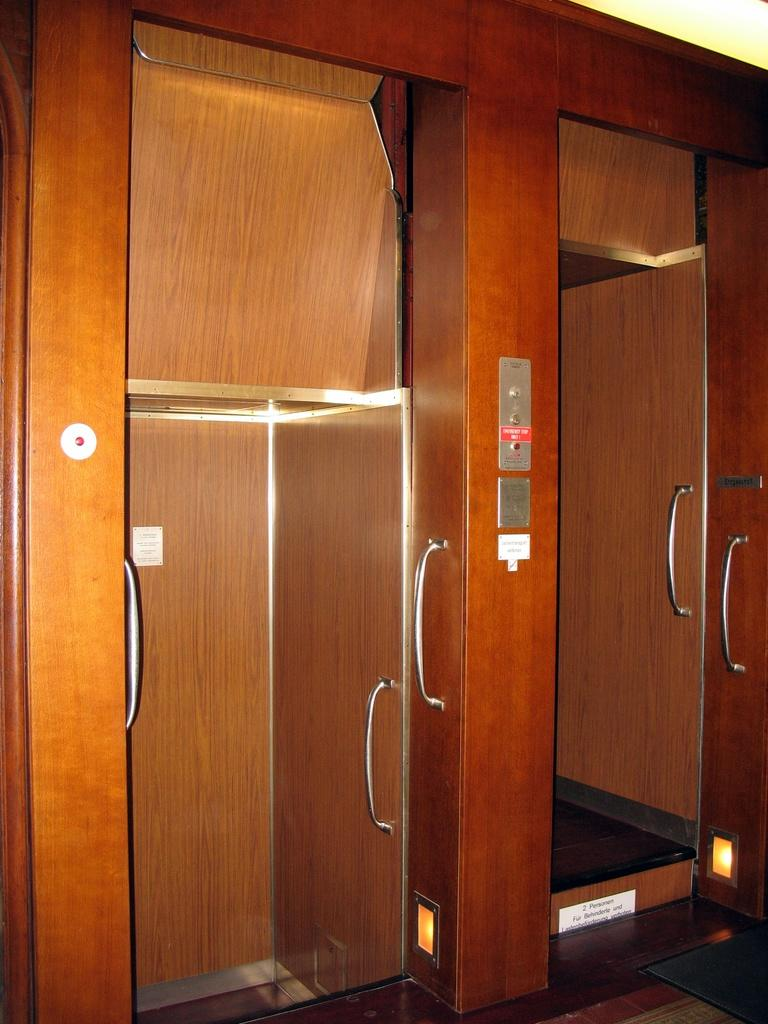What can be seen in the foreground of the image? There are two elevators in the foreground of the image. What is located in the middle of the image? There are buttons in the middle of the image. Can you see a spy hiding behind the buttons in the image? There is no indication of a spy or any hidden figure in the image; it only shows two elevators and buttons. 